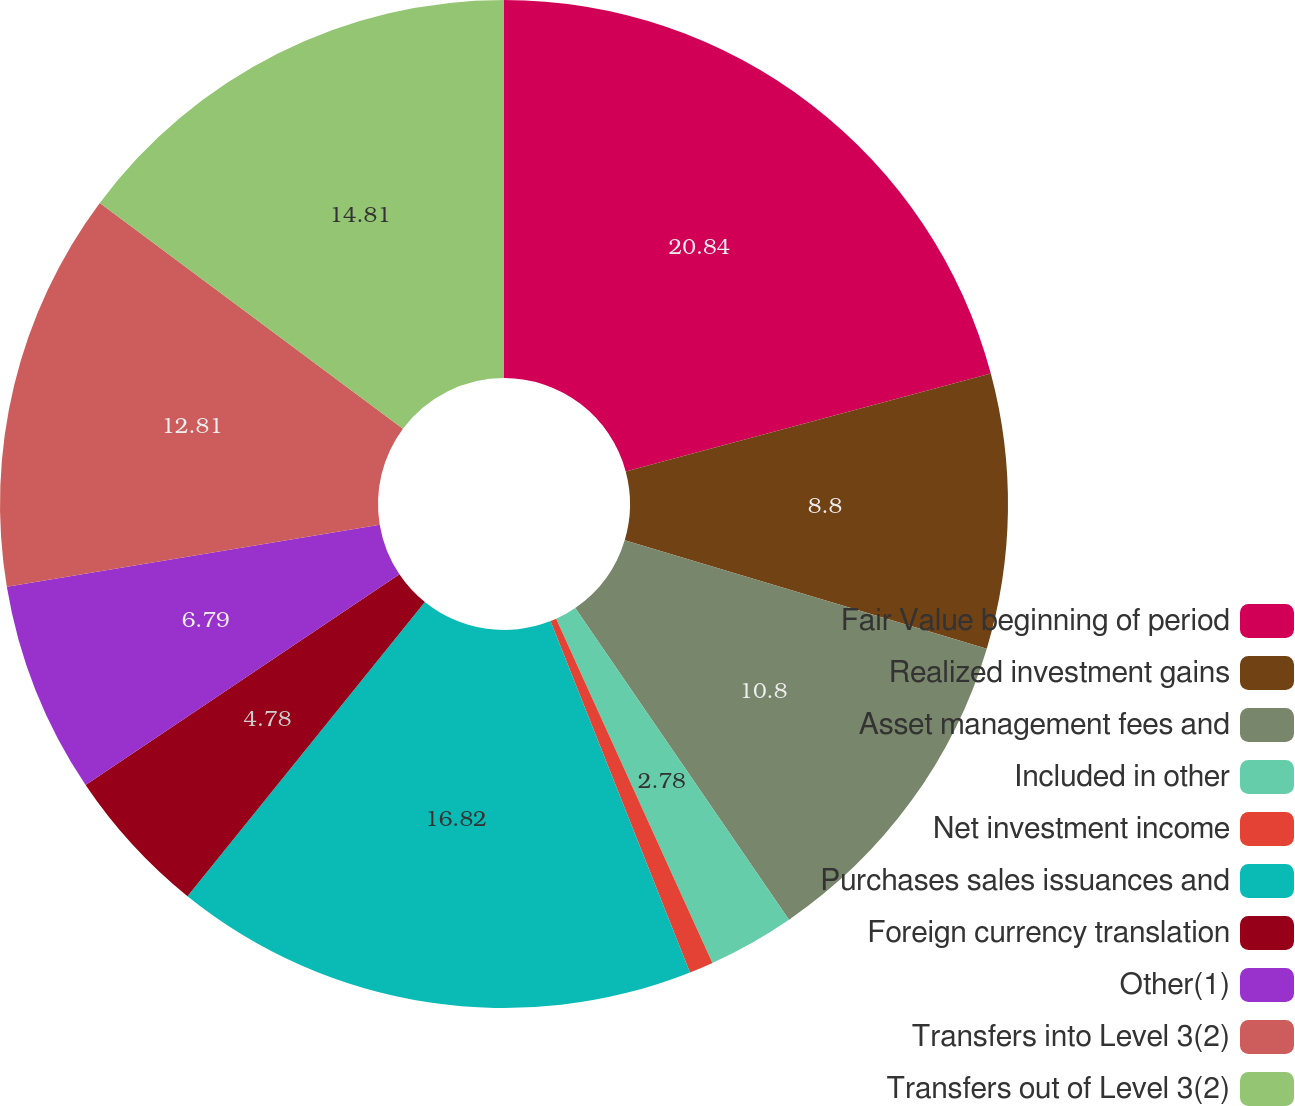<chart> <loc_0><loc_0><loc_500><loc_500><pie_chart><fcel>Fair Value beginning of period<fcel>Realized investment gains<fcel>Asset management fees and<fcel>Included in other<fcel>Net investment income<fcel>Purchases sales issuances and<fcel>Foreign currency translation<fcel>Other(1)<fcel>Transfers into Level 3(2)<fcel>Transfers out of Level 3(2)<nl><fcel>20.83%<fcel>8.8%<fcel>10.8%<fcel>2.78%<fcel>0.77%<fcel>16.82%<fcel>4.78%<fcel>6.79%<fcel>12.81%<fcel>14.81%<nl></chart> 